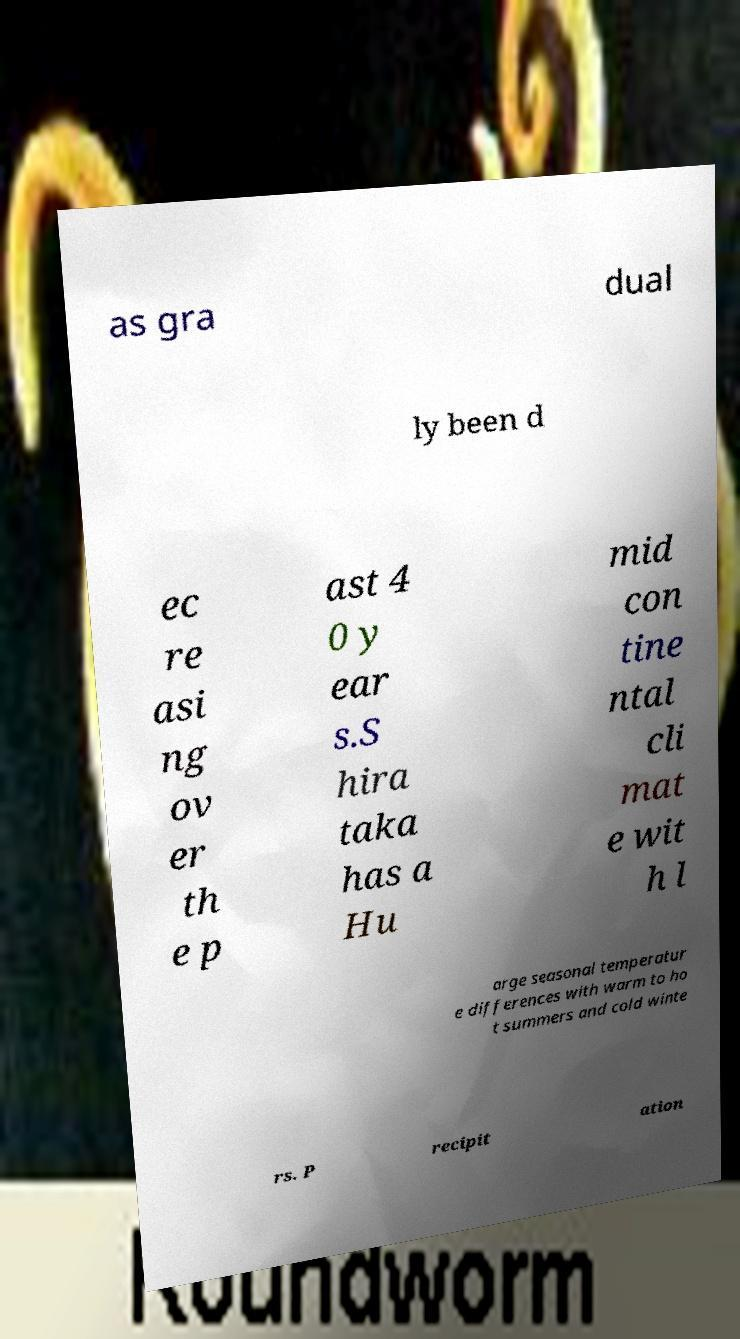What messages or text are displayed in this image? I need them in a readable, typed format. as gra dual ly been d ec re asi ng ov er th e p ast 4 0 y ear s.S hira taka has a Hu mid con tine ntal cli mat e wit h l arge seasonal temperatur e differences with warm to ho t summers and cold winte rs. P recipit ation 